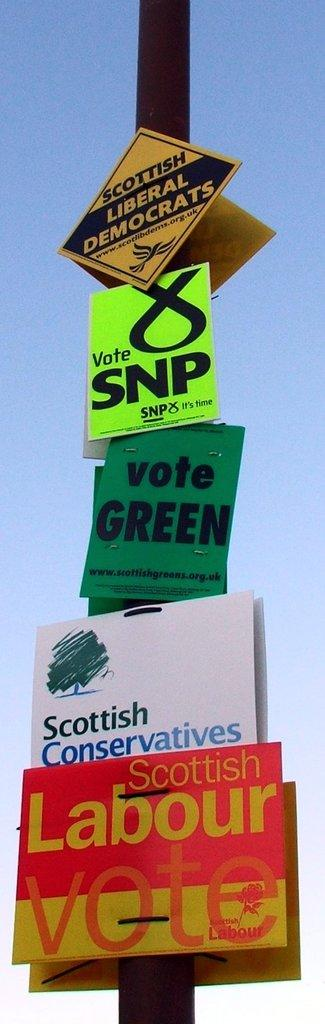<image>
Write a terse but informative summary of the picture. An assortment of political posters are attached to a pole, including signs for the Scottish Labour Vote, Scottish Conservatives, and the SNP. 